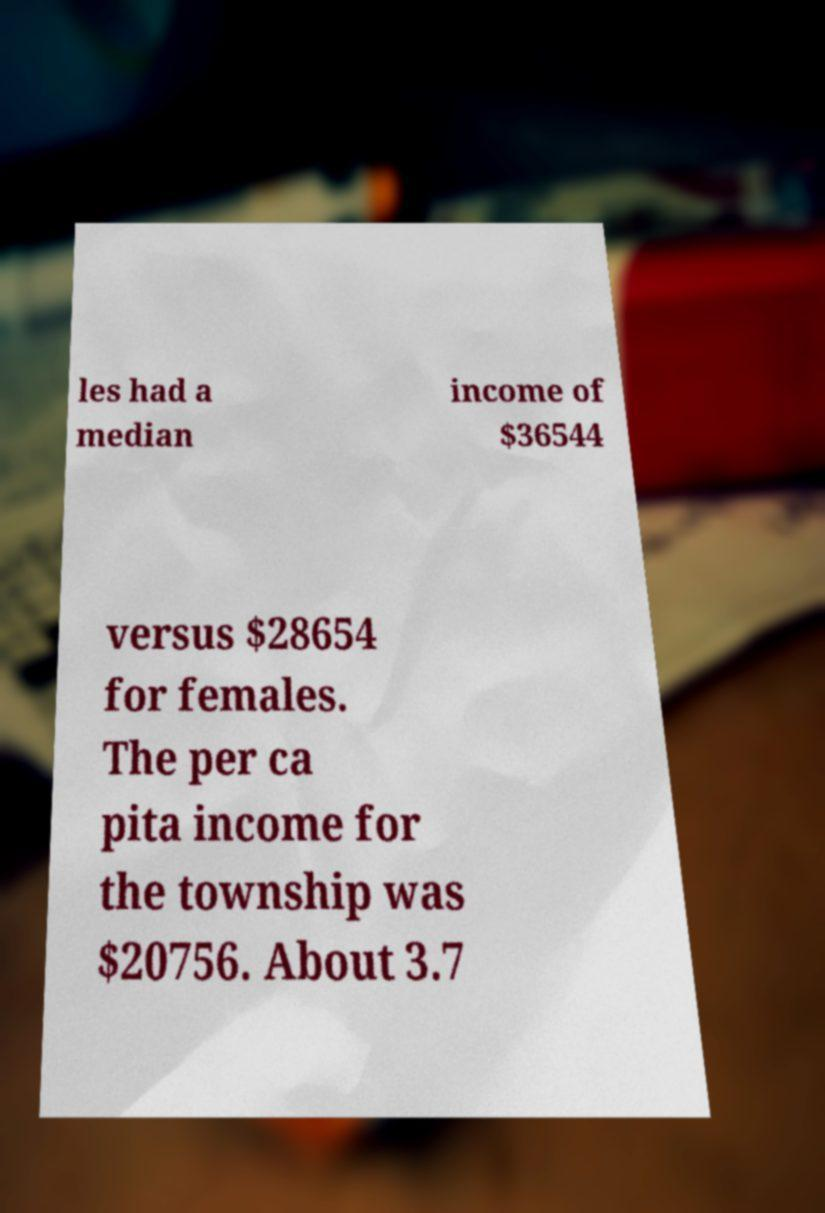Please identify and transcribe the text found in this image. les had a median income of $36544 versus $28654 for females. The per ca pita income for the township was $20756. About 3.7 